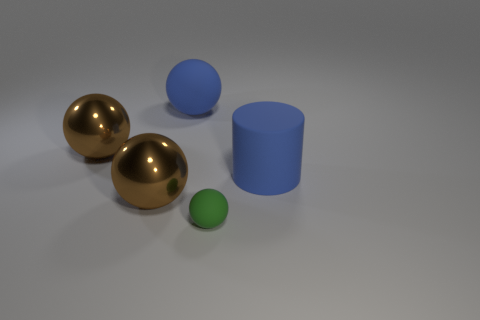Is there a matte thing of the same color as the tiny sphere? no 